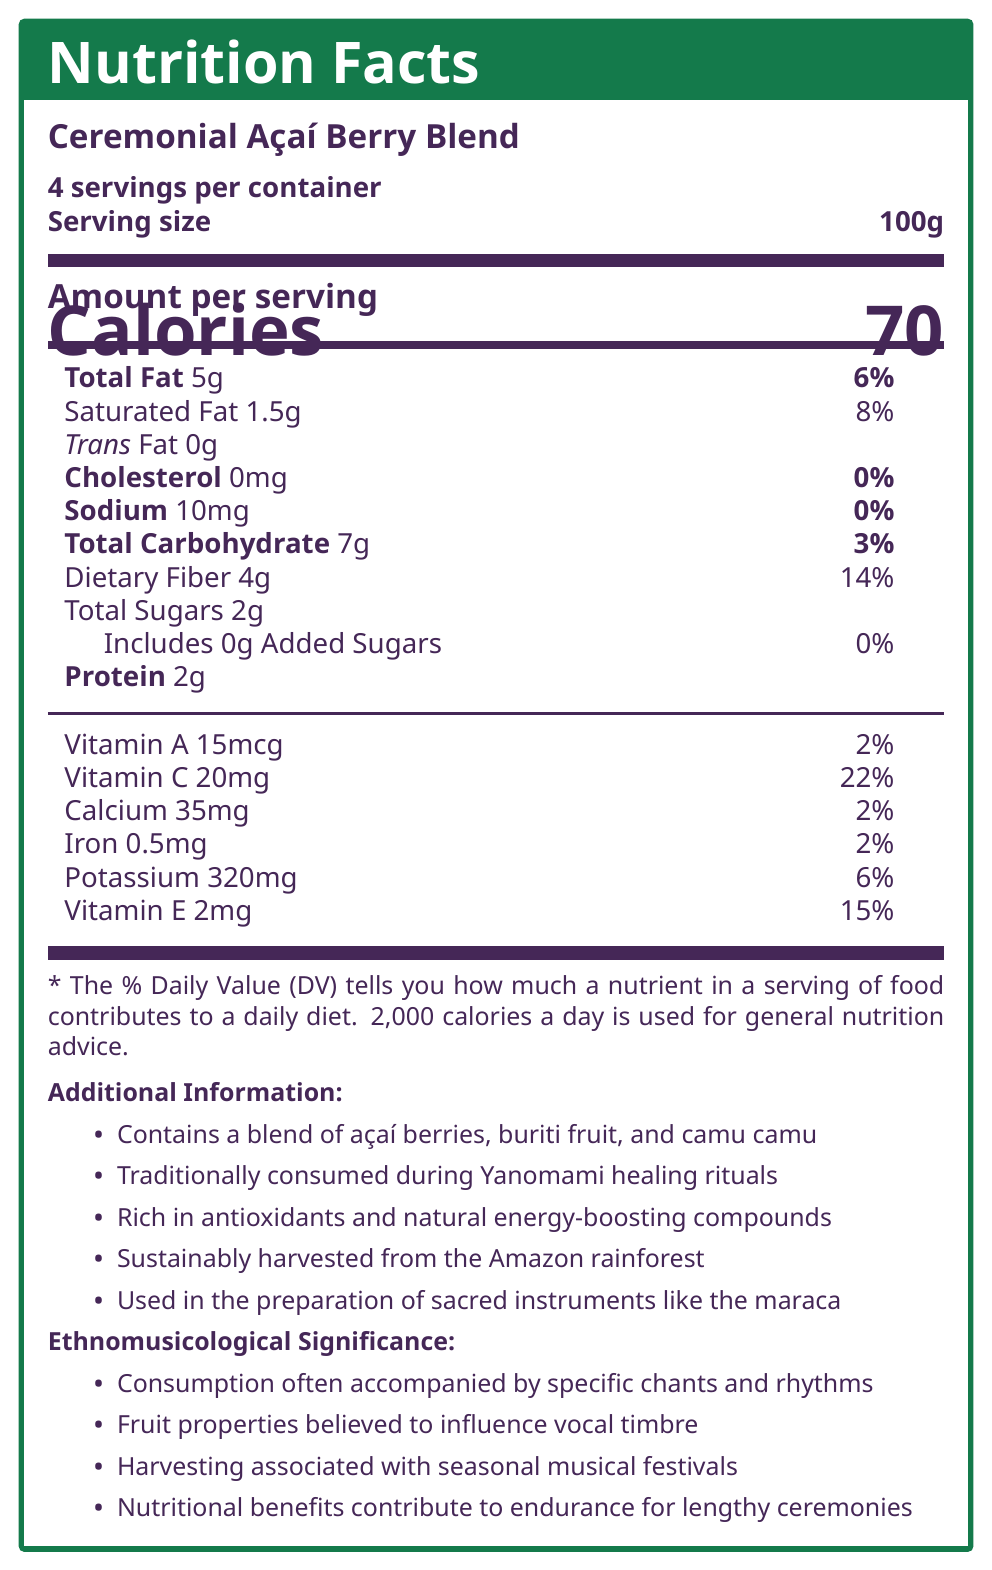what is the serving size? The serving size is mentioned explicitly in the document under the "Serving size" section.
Answer: 100g how many calories are in one serving? The calories per serving are stated as 70 under the "Amount per serving" section.
Answer: 70 how much protein does one serving contain? The protein content is listed as 2g per serving in the nutritional information table.
Answer: 2g what is the daily value percentage of dietary fiber per serving? The document mentions that dietary fiber has a daily value percentage of 14% per serving.
Answer: 14% what are the main fruits included in the Ceremonial Açaí Berry Blend? The document lists these fruits in the "Additional Information" section.
Answer: Açaí berries, buriti fruit, camu camu which vitamin has the highest daily value percentage per serving? A. Vitamin A B. Vitamin C C. Vitamin E Vitamin C has a daily value percentage of 22%, higher than Vitamin A (2%) and Vitamin E (15%).
Answer: B what is the total fat content per serving? The total fat content per serving is 5g, as stated in the document.
Answer: 5g is the Ceremonial Açaí Berry Blend sustainably harvested from the Amazon rainforest? The document explicitly mentions that the blend is sustainably harvested from the Amazon rainforest.
Answer: Yes why is the Ceremonial Açaí Berry Blend significant in ethnomusicology? The document outlines these points in the "Ethnomusicological Significance" section.
Answer: It is consumed during ceremonies, believed to influence vocal timbre, associated with musical festivals, and contributes to endurance in performances does the Ceremonial Açaí Berry Blend contain any trans fat? The document lists the trans fat content as 0g per serving.
Answer: No how many servings are there per container? The document states that there are 4 servings per container.
Answer: 4 how much vitamin C does one serving contain? The document lists the vitamin C content as 20mg per serving.
Answer: 20mg is the Ceremonial Açaí Berry Blend used in the preparation of sacred instruments? The document mentions that it is used in the preparation of sacred instruments like the maraca.
Answer: Yes describe the nutritional and cultural significance of the Ceremonial Açaí Berry Blend. The document provides detailed nutritional information and describes its cultural uses, significance in rituals, and ethnomusicological importance.
Answer: The Ceremonial Açaí Berry Blend is a nutritional product with 70 calories per serving, rich in antioxidants, low in sugars, and a good source of dietary fiber, vitamins, and minerals. Culturally, it is significant in various indigenous Amazonian practices, including healing rituals, musical ceremonies, and is believed to influence vocal performances, provide stamina, and support the creation of sacred instruments. how much potassium does one serving have? The document lists potassium content as 320mg per serving.
Answer: 320mg how much added sugar is in one serving? The document states that there are 0g of added sugars per serving.
Answer: 0g what role does the Ceremonial Açaí Berry Blend play in Yanomami healing rituals? The document states it is traditionally consumed during Yanomami healing rituals but does not specify the exact role it plays.
Answer: "Not mentioned explicitly" what type of body paint ingredients does the Kayapo tribe use in their music and dance ceremonies? The document says the blend is used as a natural dye for body paint in Kayapo ceremonies but does not provide specific ingredients used by the Kayapo tribe.
Answer: Not enough information which tribe incorporates this blend into their diet to improve breath control for flute playing? A. Yanomami B. Tikuna C. Waiwai The document mentions that the Tikuna incorporate this blend into their diet to improve breath control for flute playing.
Answer: B 